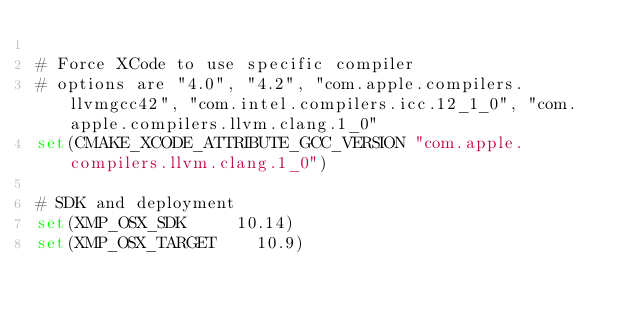<code> <loc_0><loc_0><loc_500><loc_500><_CMake_>
# Force XCode to use specific compiler
# options are "4.0", "4.2", "com.apple.compilers.llvmgcc42", "com.intel.compilers.icc.12_1_0", "com.apple.compilers.llvm.clang.1_0"
set(CMAKE_XCODE_ATTRIBUTE_GCC_VERSION "com.apple.compilers.llvm.clang.1_0")

# SDK and deployment 
set(XMP_OSX_SDK		 	10.14)
set(XMP_OSX_TARGET	 	10.9)
</code> 